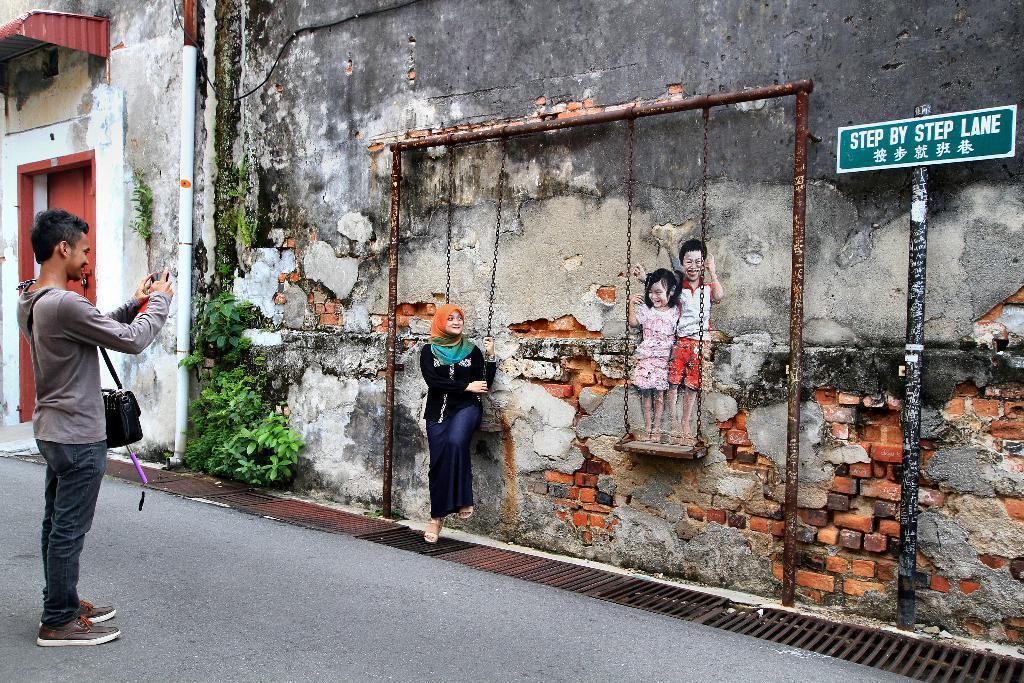How would you summarize this image in a sentence or two? On the left side of the image there is a man standing and he wore a bag. He is holding an object in his hand. In front of him there is a wall with paintings of two kids. In front of the wall there are poles with cradles. There is a lady sitting on the cradle. On the right side of the image there is a pole with a sign board. And also there are leaves. On the left side corner of the image beside the man there is a door and also there is a roof. And on the side of the road there is a drainage grill. 